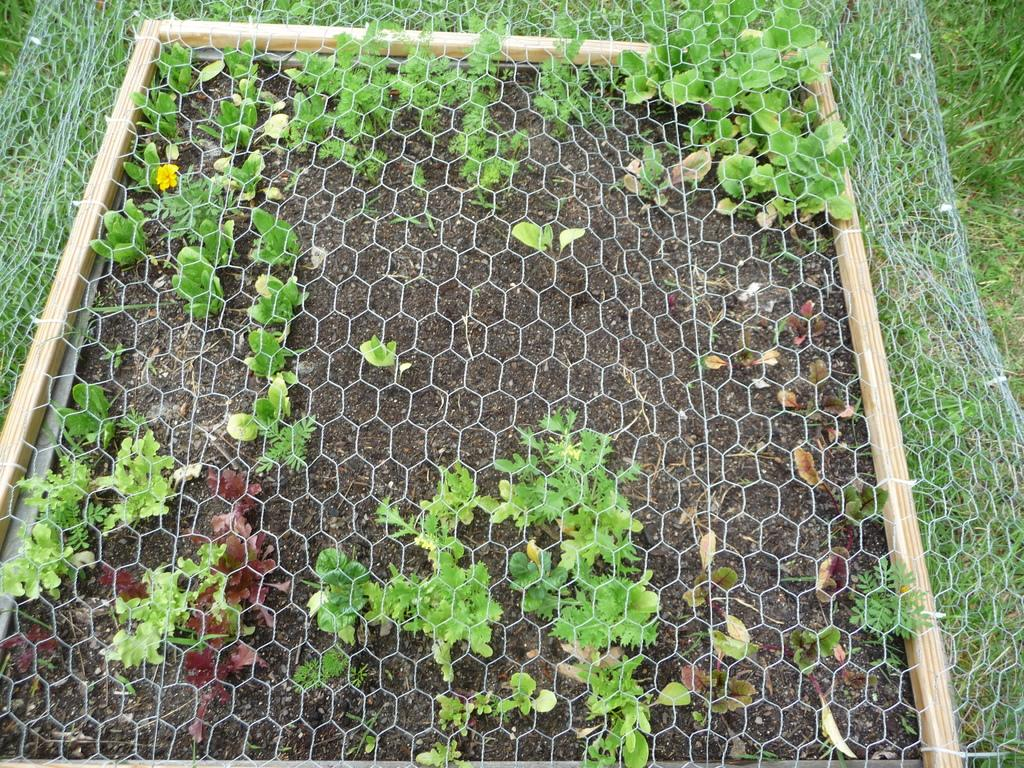What type of living organisms can be seen in the image? Plants can be seen in the image. What type of structure is present in the image? There is a fence in the image. What type of connection is being used by the plants in the image? There is no indication of any connection being used by the plants in the image. 